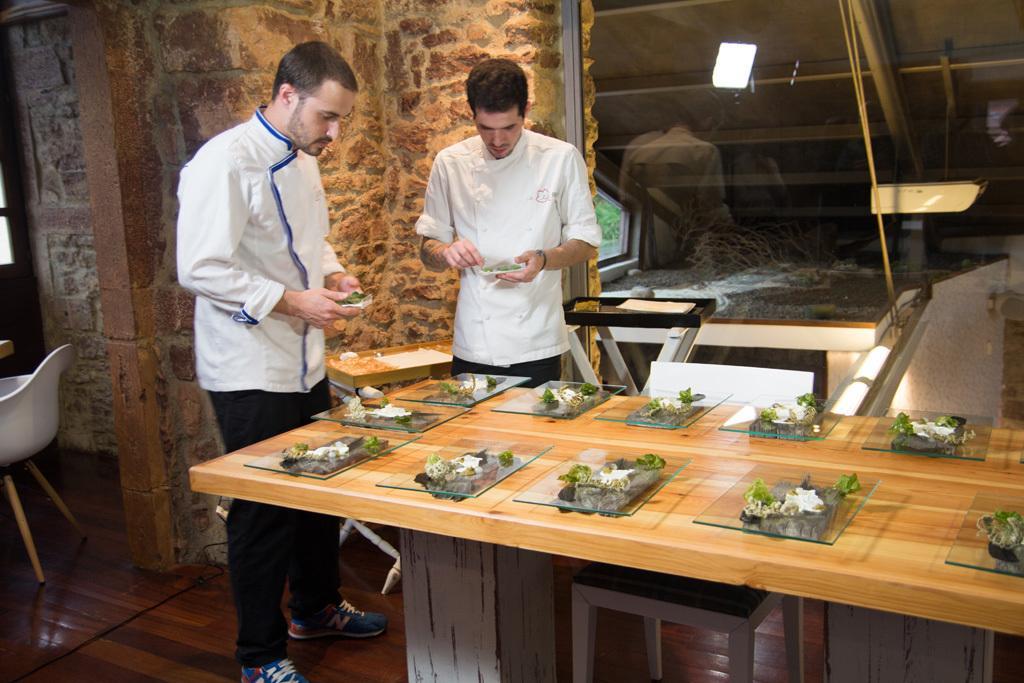Can you describe this image briefly? In this image I see 2 men who are standing and they are holding something in their hands. I can see a table over here and there are lot of things on it. In the background I see the wall, glass and a chair over here. 